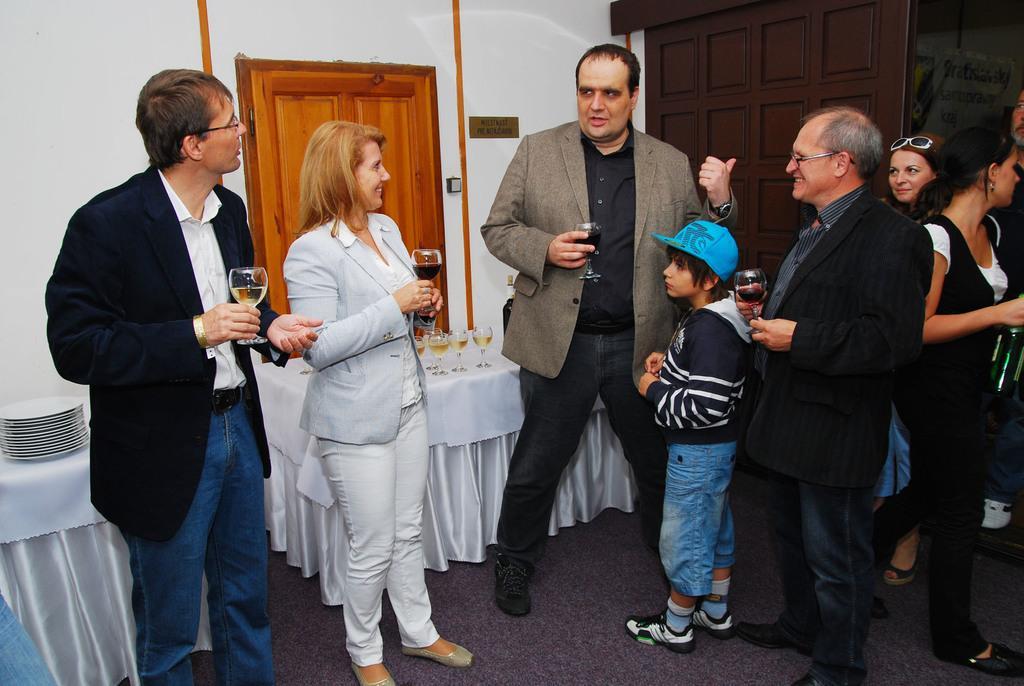In one or two sentences, can you explain what this image depicts? In the center of the image we can see people standing and holding wine glasses. In the background there are tables and we can see glasses and plates on the tables. We can see doors and a wall. 